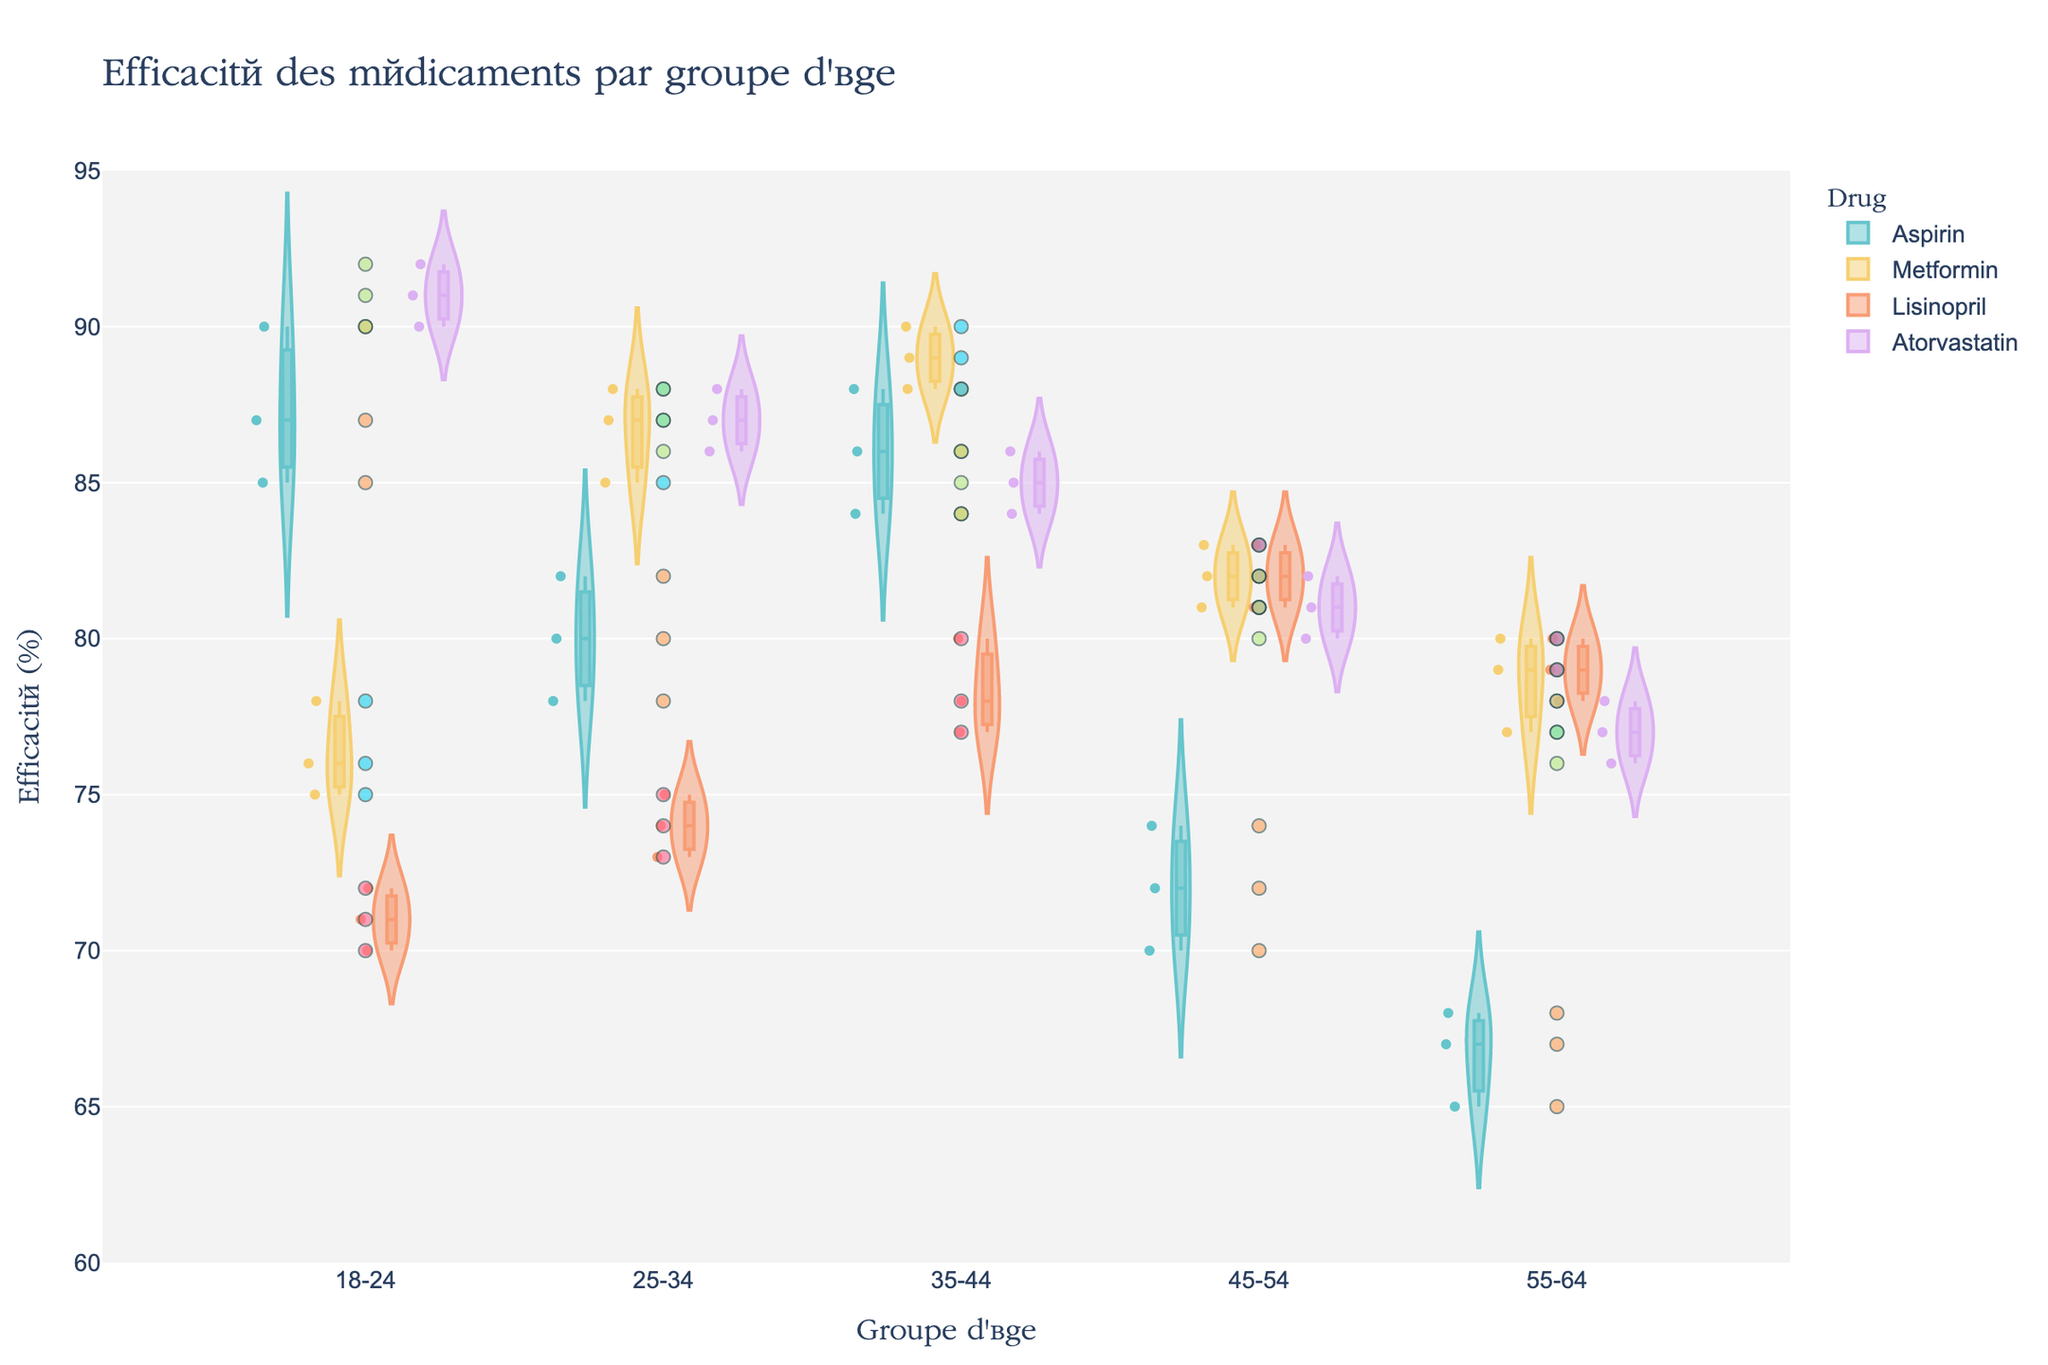What is the title of the figure? The title of the figure can be found at the top of the image. It reads "Efficacité des médicaments par groupe d'âge".
Answer: Efficacité des médicaments par groupe d'âge Which age group has the highest median efficacy for Aspirin? By examining the violin plots and their associated box plots for Aspirin, the age group with the highest median (middle line in the box plot) can be identified. The age group 35-44 has the highest median efficacy for Aspirin.
Answer: 35-44 How does the efficacy of Metformin in the 18-24 age group compare to that in the 25-34 age group? By comparing the violin plots of Metformin for both age groups, it's evident that the efficacy rates in the 25-34 age group are higher than those in the 18-24 age group. This is indicated by the shapes and positions of the plots as well as the jittered points and medians.
Answer: 25-34 > 18-24 What is the average efficacy of Atorvastatin across all age groups? To find the average efficacy of Atorvastatin, note down the efficacy values in each age group ([90, 92, 91], [88, 86, 87], [85, 84, 86], [80, 81, 82], [76, 78, 77]). Sum these values and divide by the total number of values: (90+92+91+88+86+87+85+84+86+80+81+82+76+78+77)/15 = 83.1333.
Answer: 83.13 Which drug has the most consistent efficacy in the 55-64 age group? Consistency can be assessed by looking at the spread of the jittered points and the width of the violin plots. Metformin in the 55-64 age group shows less spread and a narrower violin plot compared to others, indicating higher consistency.
Answer: Metformin What is the range of efficacy for Lisinopril in the 35-44 age group? The range is determined by the minimum and maximum efficacy values within the jittered points for this age group. For Lisinopril in the 35-44 age group, the efficacy values are 77, 78, and 80. Thus, the range is 80 - 77 = 3.
Answer: 3 How do the efficacies of Metformin and Aspirin compare in the 45-54 age group? By comparing their violin plots, Metformin has a higher median efficacy compared to Aspirin. The distributions also show that the overall efficacy values for Metformin are higher than those for Aspirin in this age group.
Answer: Metformin > Aspirin What is the difference in median efficacy between the 25-34 and 55-64 age groups for Aspirin? The median efficacy for Aspirin in the 25-34 age group is approximately 80, while for the 55-64 age group it is approximately 67. The difference is 80 - 67 = 13.
Answer: 13 